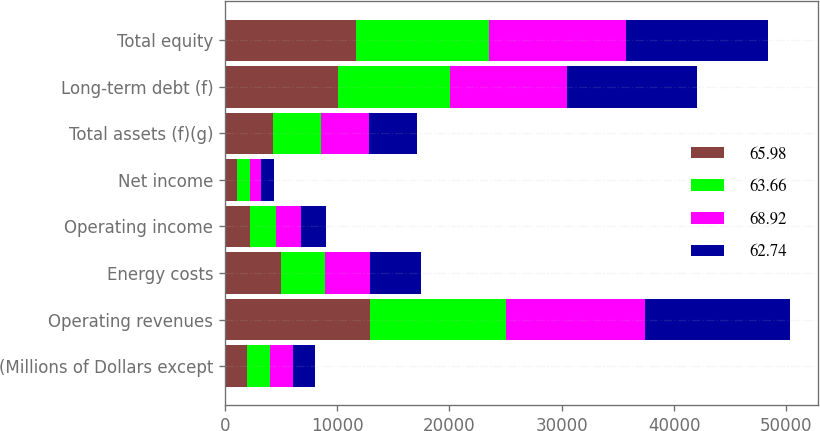Convert chart to OTSL. <chart><loc_0><loc_0><loc_500><loc_500><stacked_bar_chart><ecel><fcel>(Millions of Dollars except<fcel>Operating revenues<fcel>Energy costs<fcel>Operating income<fcel>Net income<fcel>Total assets (f)(g)<fcel>Long-term debt (f)<fcel>Total equity<nl><fcel>65.98<fcel>2011<fcel>12886<fcel>5001<fcel>2239<fcel>1062<fcel>4283.5<fcel>10068<fcel>11649<nl><fcel>63.66<fcel>2012<fcel>12188<fcel>3887<fcel>2339<fcel>1141<fcel>4283.5<fcel>9994<fcel>11869<nl><fcel>68.92<fcel>2013<fcel>12354<fcel>4054<fcel>2244<fcel>1062<fcel>4283.5<fcel>10415<fcel>12245<nl><fcel>62.74<fcel>2014<fcel>12919<fcel>4513<fcel>2209<fcel>1092<fcel>4283.5<fcel>11546<fcel>12585<nl></chart> 